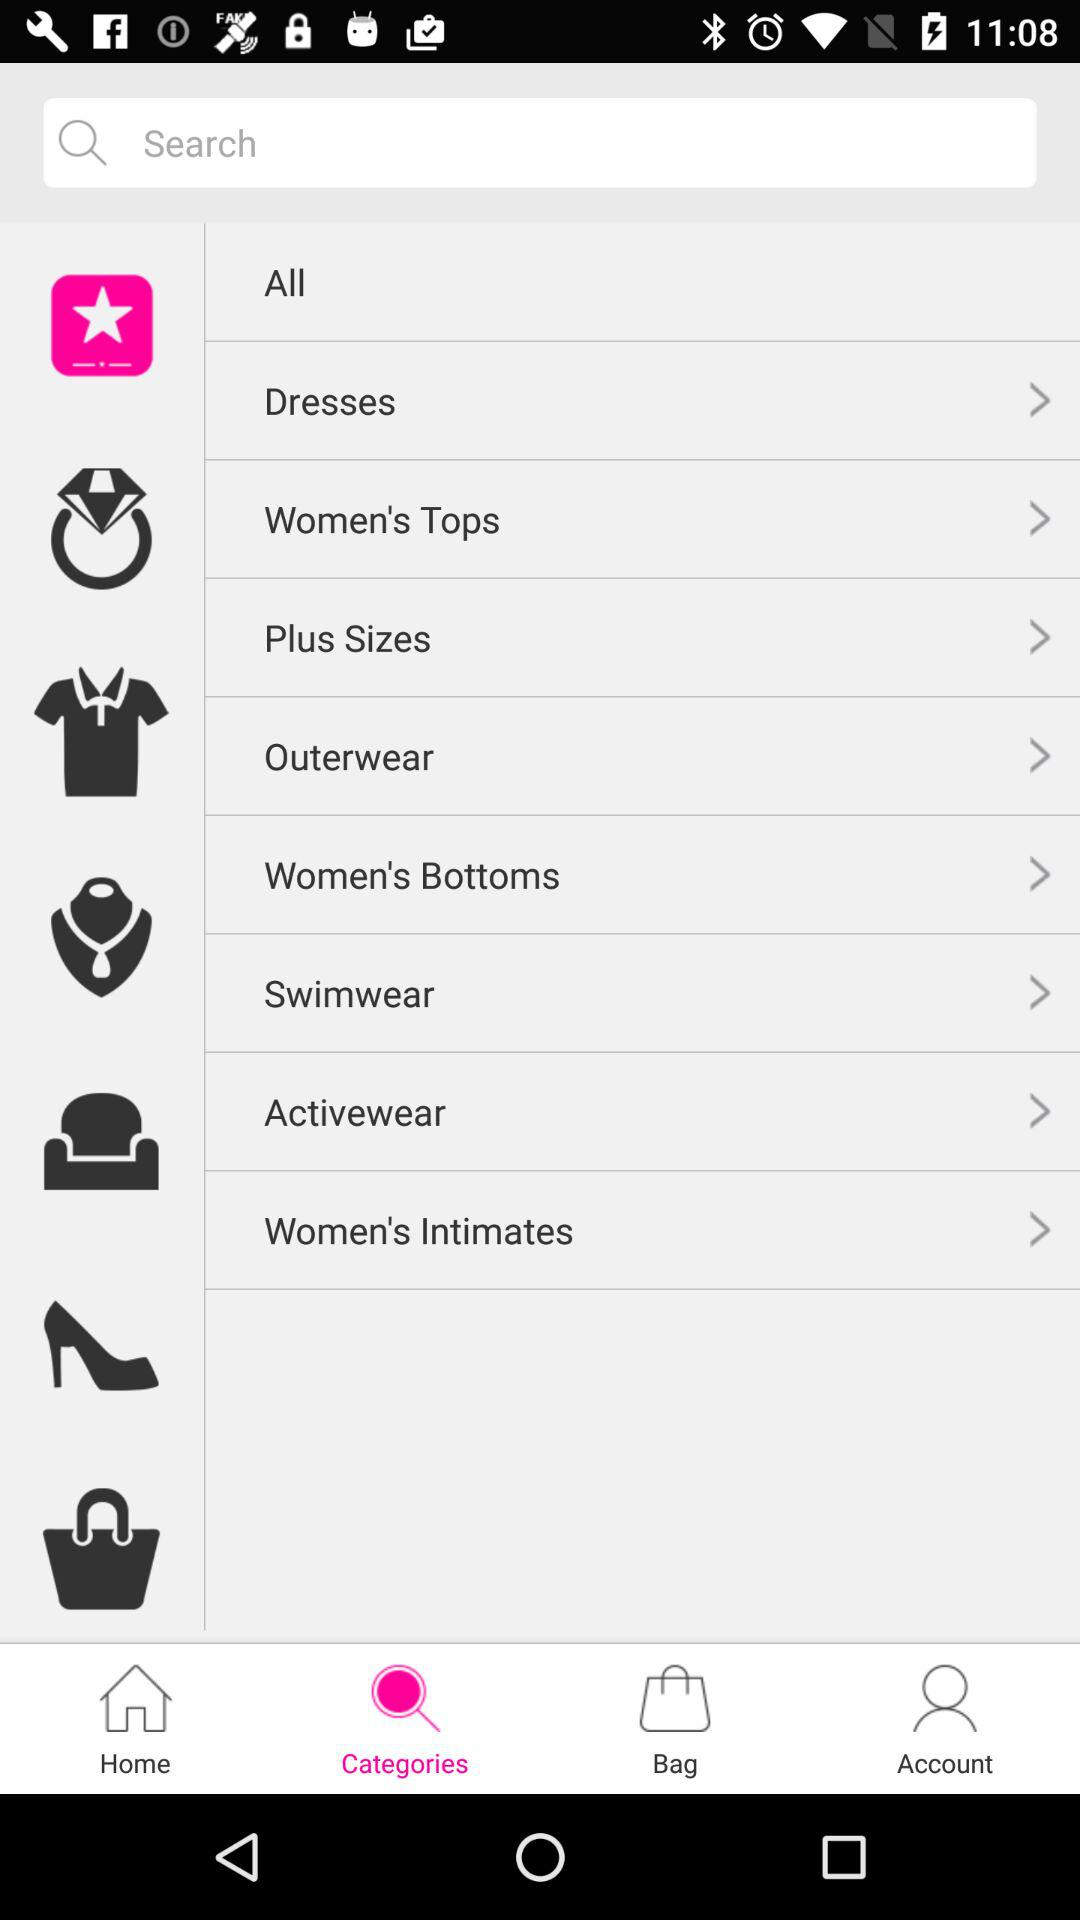How many types of women's apparel are available in the option? The available types of women's apparel are "Dresses", "Women's Tops", "Plus Sizes", "Outerwear", "Women's Bottoms", "Swimwear", "Activewear" and "Women's Intimates". 